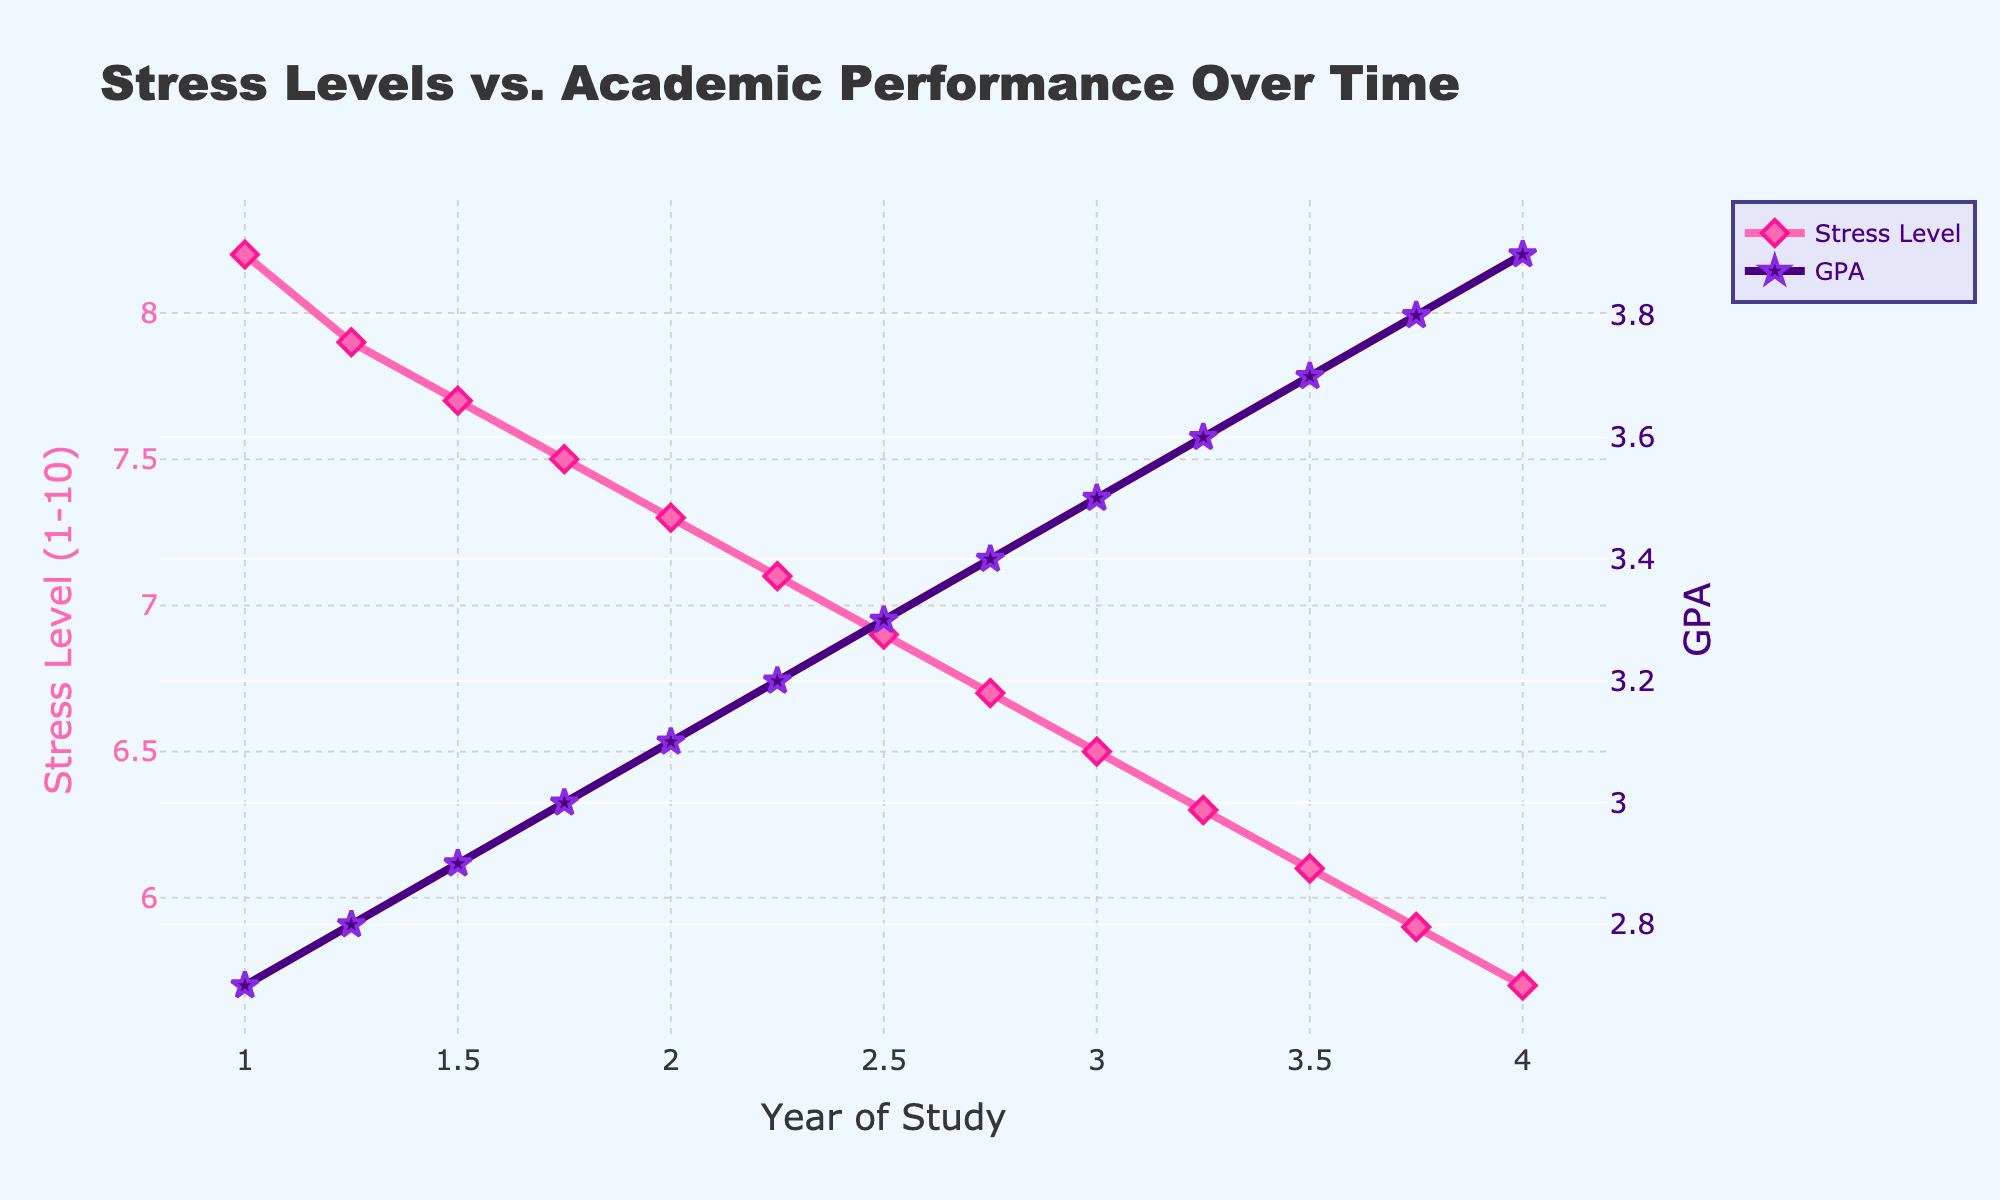What's the trend of stress levels over the four years of study? To determine the trend, observe the line representing stress levels from year 1 to year 4. It shows a general decline. At year 1, the stress level starts at 8.2 and gradually decreases to 5.7 by year 4. Thus, the trend shows that stress levels are decreasing over time.
Answer: Decreasing How does academic performance change from year 1 to year 4? To answer, look at the academic performance line. It starts at a GPA of 2.7 in year 1 and ascends to 3.9 by year 4. This indicates that academic performance is increasing over the four years.
Answer: Increasing What is the difference in stress levels between year 1 and year 4? Identify the stress level at year 1 (8.2) and year 4 (5.7). Subtract the year 4 value from the year 1 value: 8.2 - 5.7 = 2.5.
Answer: 2.5 Which year has the highest stress level, and what is its value? Examine the line plot for stress levels. The highest stress level is 8.2, occurring in year 1.
Answer: Year 1, 8.2 What is the median GPA value across the study years? First, list all GPA values: 2.7, 2.8, 2.9, 3.0, 3.1, 3.2, 3.3, 3.4, 3.5, 3.6, 3.7, 3.8, 3.9. The median is the middle value in an ordered list, which is the 7th value: 3.3.
Answer: 3.3 During which year(s) do stress levels and GPA show the most significant change? Compare the slope of lines between consecutive years for both stress levels and GPA. The most noticeable changes appear between year 1.75 and year 2 for both metrics. Stress levels drop from 7.5 to 7.3 (change of 0.2) and GPA increases from 3.0 to 3.1 (change of 0.1).
Answer: Year 1.75 to 2 Is there a point where stress levels and GPA appear inversely related? Inspect the plot's patterns for an inverse relationship, where an increase in one corresponds to a decrease in the other. Throughout the plot, as stress levels decrease, GPA increases, suggesting an inverse relationship all the way through.
Answer: Yes, generally throughout What are the values of stress level and GPA at year 2.75? Locate the data points for year 2.75 on the plot. The stress level is 6.7, and the GPA is 3.4.
Answer: Stress: 6.7, GPA: 3.4 Compare the growth rates of GPA in the first and the last two years. Calculate the GPA increase in the first two years (from 2.7 to 3.1) and the last two years (from 3.5 to 3.9). Both periods show an increase of 0.4 points.
Answer: Same growth (0.4) 